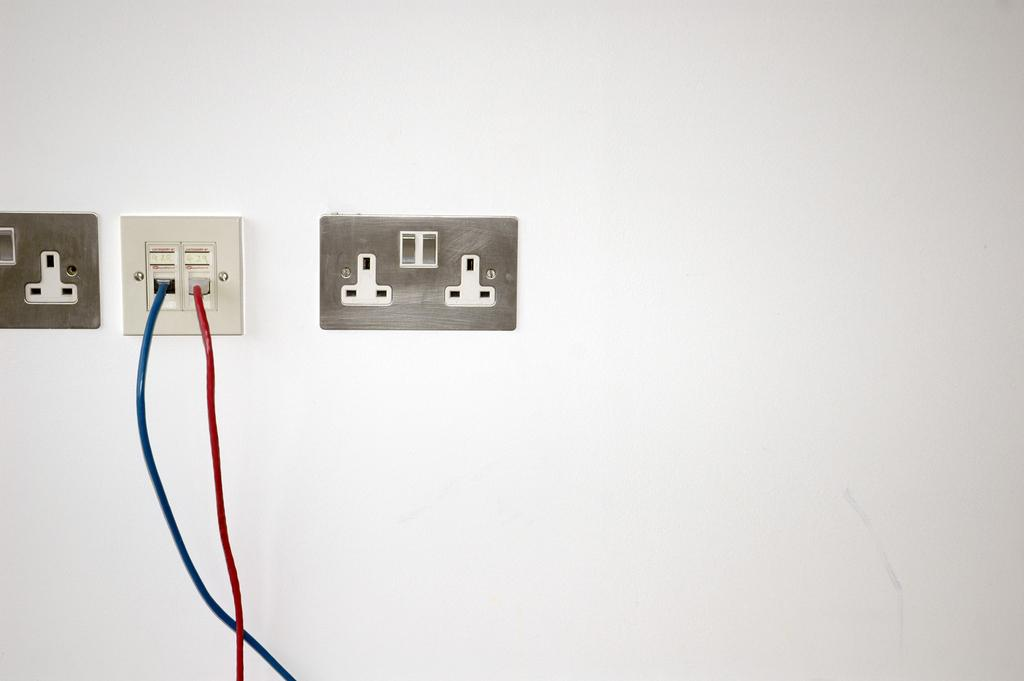What can be seen in the image that is used for connecting electrical devices? There are sockets in the image. What is connected to the sockets in the image? There are cables in the image. What type of structure is visible in the background of the image? There is a wall in the image. What type of sound can be heard coming from the sockets in the image? There is no sound coming from the sockets in the image, as they are inanimate objects used for connecting electrical devices. 